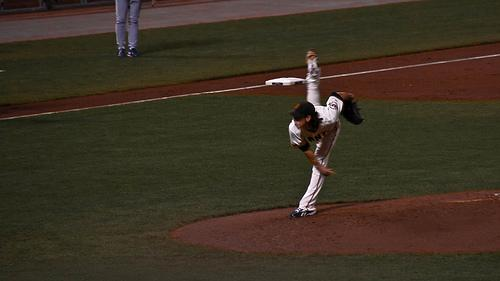Question: who is in the photo?
Choices:
A. A jug.
B. A container.
C. Glassware.
D. A pitcher.
Answer with the letter. Answer: D Question: what color are the pitcher's pants?
Choices:
A. White.
B. Black.
C. Red.
D. Green.
Answer with the letter. Answer: A Question: what does the pitcher have on his head?
Choices:
A. Cap.
B. Helmet.
C. A hat.
D. Protection.
Answer with the letter. Answer: C Question: where is this picture taken?
Choices:
A. A sports field.
B. At the game.
C. A baseball diamond.
D. With the team.
Answer with the letter. Answer: C 